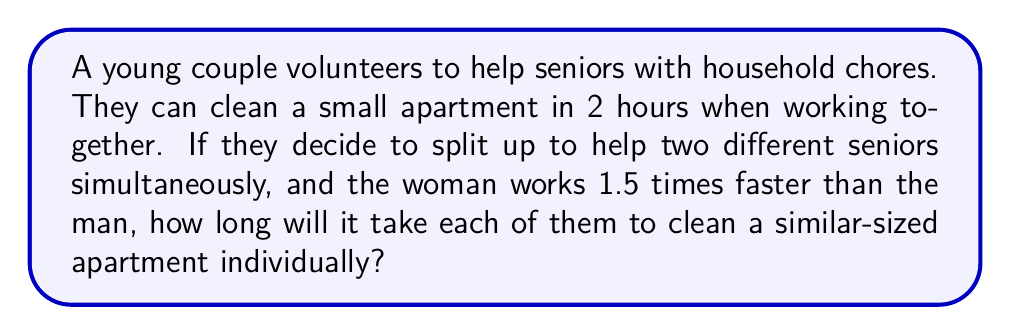Teach me how to tackle this problem. Let's approach this step-by-step:

1) First, let's define variables:
   $t_m$ = time taken by the man
   $t_w$ = time taken by the woman

2) We know that the woman works 1.5 times faster than the man, so:
   $t_m = 1.5t_w$

3) When they work together, they clean the apartment in 2 hours. This means their combined rate is $\frac{1}{2}$ apartment per hour.

4) The rate at which they work together is the sum of their individual rates:
   $\frac{1}{t_m} + \frac{1}{t_w} = \frac{1}{2}$

5) Substituting $t_m = 1.5t_w$ from step 2:
   $\frac{1}{1.5t_w} + \frac{1}{t_w} = \frac{1}{2}$

6) Finding a common denominator:
   $\frac{2}{3t_w} + \frac{3}{3t_w} = \frac{1}{2}$

7) Simplifying:
   $\frac{5}{3t_w} = \frac{1}{2}$

8) Solving for $t_w$:
   $t_w = \frac{5}{3} \cdot \frac{2}{1} = \frac{10}{3} = 3\frac{1}{3}$ hours

9) Since $t_m = 1.5t_w$:
   $t_m = 1.5 \cdot \frac{10}{3} = 5$ hours

Therefore, it will take the woman 3 hours and 20 minutes, and the man 5 hours to clean a similar-sized apartment individually.
Answer: The woman will take 3 hours and 20 minutes (or $3\frac{1}{3}$ hours), and the man will take 5 hours. 